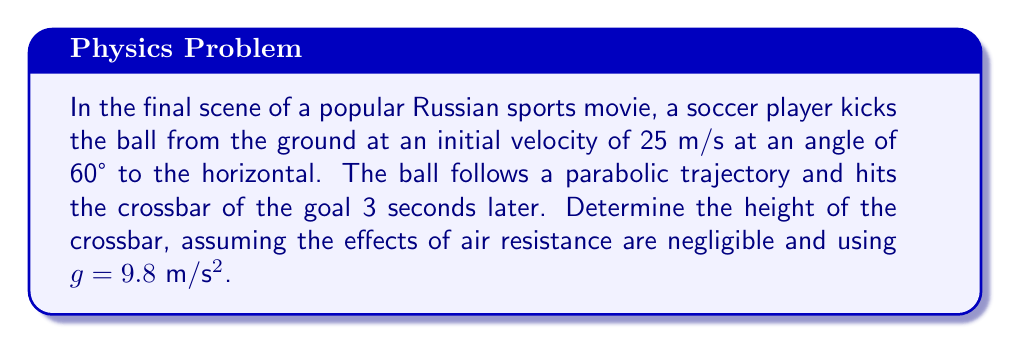Solve this math problem. 1. The trajectory of the soccer ball can be described by a parabolic equation. We'll use the parametric equations for projectile motion:

   $x(t) = v_0 \cos(\theta) \cdot t$
   $y(t) = v_0 \sin(\theta) \cdot t - \frac{1}{2}gt^2$

   Where $v_0$ is the initial velocity, $\theta$ is the angle of projection, $t$ is time, and $g$ is the acceleration due to gravity.

2. Given information:
   $v_0 = 25$ m/s
   $\theta = 60°$
   $t = 3$ s
   $g = 9.8$ m/s²

3. To find the height of the crossbar, we need to calculate $y(3)$:

   $y(3) = v_0 \sin(\theta) \cdot 3 - \frac{1}{2}g \cdot 3^2$

4. First, let's calculate $\sin(60°)$:
   $\sin(60°) = \frac{\sqrt{3}}{2} \approx 0.866$

5. Now, let's substitute the values into the equation:

   $y(3) = 25 \cdot 0.866 \cdot 3 - \frac{1}{2} \cdot 9.8 \cdot 3^2$
   $y(3) = 64.95 - 44.1$
   $y(3) = 20.85$ m

6. Therefore, the height of the crossbar is approximately 20.85 meters.
Answer: 20.85 m 